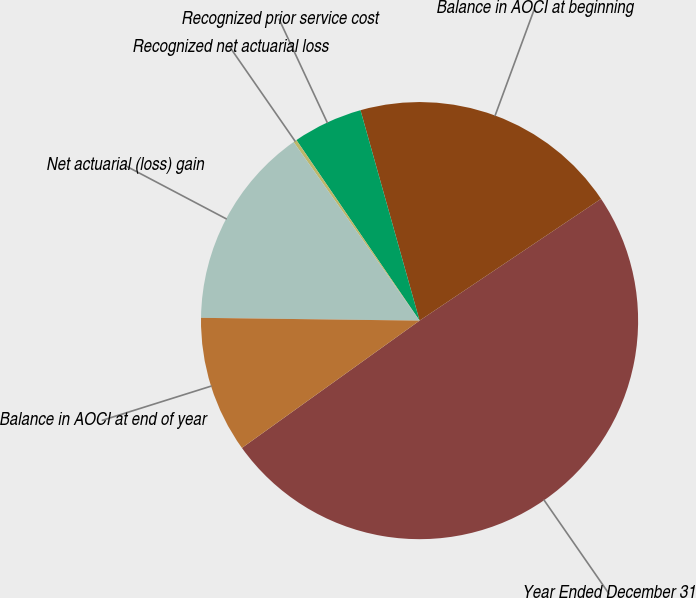Convert chart. <chart><loc_0><loc_0><loc_500><loc_500><pie_chart><fcel>Year Ended December 31<fcel>Balance in AOCI at beginning<fcel>Recognized prior service cost<fcel>Recognized net actuarial loss<fcel>Net actuarial (loss) gain<fcel>Balance in AOCI at end of year<nl><fcel>49.51%<fcel>19.95%<fcel>5.17%<fcel>0.25%<fcel>15.02%<fcel>10.1%<nl></chart> 